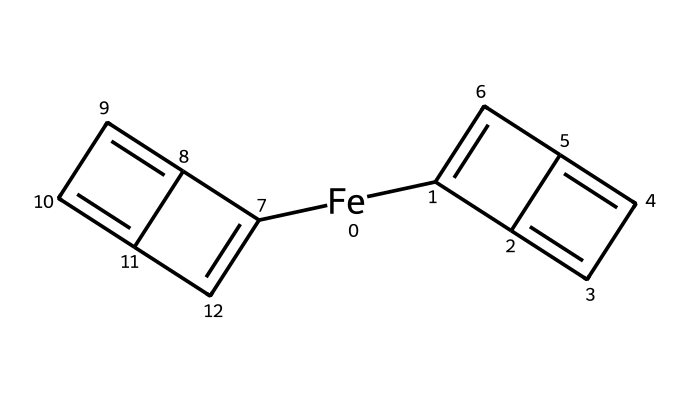What is the central metal atom in this compound? The metal in the structure can be identified from the SMILES notation, where [Fe] indicates the presence of iron. Hence, the central atom is iron.
Answer: iron How many cyclic structures are present in ferrocene? By analyzing the structure, it contains two cyclopentadienyl rings, which are closed-loop structures indicative of its unique sandwich arrangement.
Answer: two What type of bonding is primarily found in ferrocene? The bonding in this compound consists mainly of coordination bonds, as the cyclopentadienyl anion coordinates with the iron center through π-bonds.
Answer: coordination Which substituent groups can be inferred from the structure of ferrocene? The visual representation shows two cyclopentadienyl rings directly attached to the central iron atom, indicating that the substituent groups are the cyclopentadienyl anions.
Answer: cyclopentadienyl What is the molecular formula of ferrocene? The molecular formula can be derived from the composition indicated by the SMILES representation, which includes 10 carbon atoms and 10 hydrogen atoms along with 1 iron atom, leading to the formula C10H10Fe.
Answer: C10H10Fe Is ferrocene a solid, liquid, or gas at room temperature? Based on known properties of ferrocene, its solid-state at room temperature is evidenced by its structural configuration and typical behavior of similar complexes.
Answer: solid What type of compound is ferrocene classified as? Ferrocene is characterized as a metallocene, a subclass of organometallic compounds, distinguished by its sandwich structure containing a metal atom between two cyclopentadienyl anions.
Answer: metallocene 